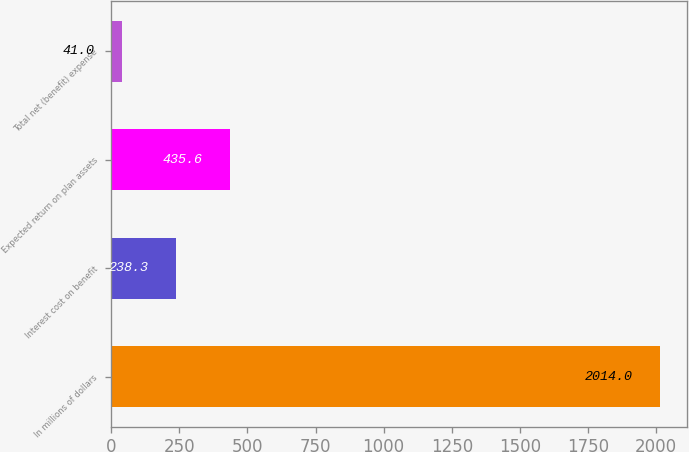Convert chart to OTSL. <chart><loc_0><loc_0><loc_500><loc_500><bar_chart><fcel>In millions of dollars<fcel>Interest cost on benefit<fcel>Expected return on plan assets<fcel>Total net (benefit) expense<nl><fcel>2014<fcel>238.3<fcel>435.6<fcel>41<nl></chart> 